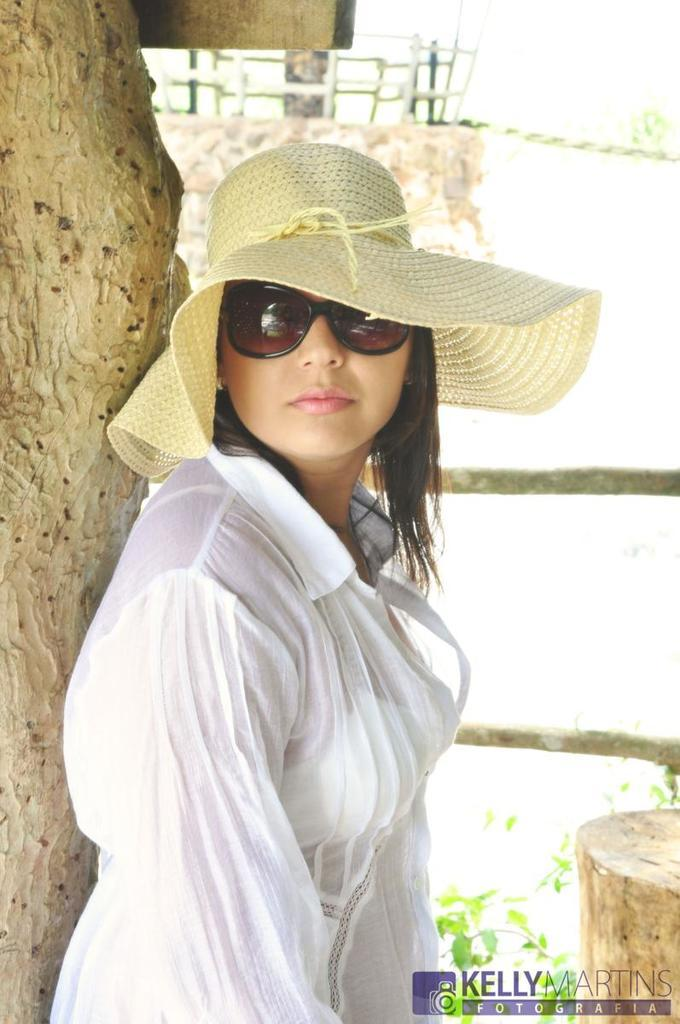Who is the main subject in the image? There is a woman standing in the middle of the image. What is visible in the background behind the woman? There are trees visible behind the woman. What is the woman's brain doing during the rainstorm in the image? There is no rainstorm present in the image, and therefore no indication of the woman's brain activity. 